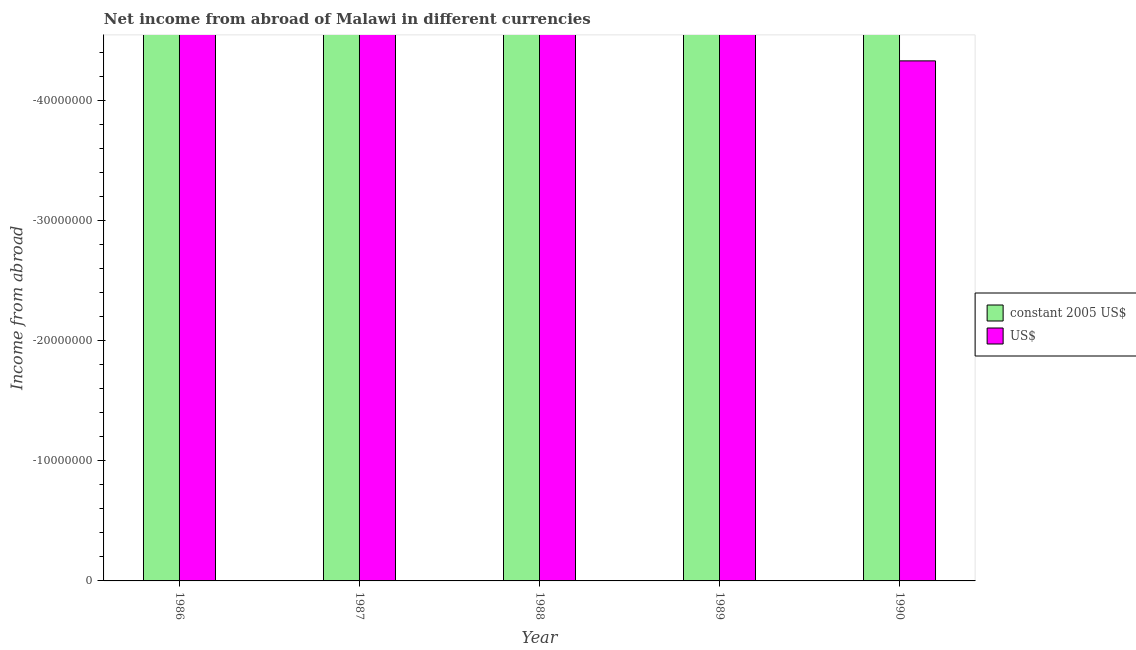Are the number of bars per tick equal to the number of legend labels?
Keep it short and to the point. No. What is the income from abroad in constant 2005 us$ in 1989?
Make the answer very short. 0. Across all years, what is the minimum income from abroad in constant 2005 us$?
Offer a very short reply. 0. What is the total income from abroad in constant 2005 us$ in the graph?
Make the answer very short. 0. What is the difference between the income from abroad in us$ in 1990 and the income from abroad in constant 2005 us$ in 1987?
Your response must be concise. 0. In how many years, is the income from abroad in constant 2005 us$ greater than -40000000 units?
Your answer should be compact. 0. Are all the bars in the graph horizontal?
Offer a terse response. No. What is the difference between two consecutive major ticks on the Y-axis?
Your response must be concise. 1.00e+07. Does the graph contain any zero values?
Your answer should be very brief. Yes. Where does the legend appear in the graph?
Ensure brevity in your answer.  Center right. How many legend labels are there?
Your answer should be compact. 2. What is the title of the graph?
Ensure brevity in your answer.  Net income from abroad of Malawi in different currencies. Does "Fixed telephone" appear as one of the legend labels in the graph?
Provide a succinct answer. No. What is the label or title of the Y-axis?
Provide a short and direct response. Income from abroad. What is the Income from abroad of constant 2005 US$ in 1986?
Make the answer very short. 0. What is the Income from abroad of US$ in 1987?
Keep it short and to the point. 0. What is the Income from abroad in constant 2005 US$ in 1989?
Ensure brevity in your answer.  0. What is the Income from abroad of US$ in 1989?
Your answer should be compact. 0. What is the total Income from abroad of US$ in the graph?
Ensure brevity in your answer.  0. What is the average Income from abroad in US$ per year?
Give a very brief answer. 0. 